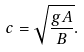Convert formula to latex. <formula><loc_0><loc_0><loc_500><loc_500>c = { \sqrt { \frac { g A } { B } } } .</formula> 